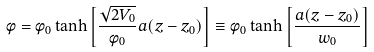<formula> <loc_0><loc_0><loc_500><loc_500>\phi = \phi _ { 0 } \tanh \left [ \frac { \sqrt { 2 V _ { 0 } } } { \phi _ { 0 } } a ( z - z _ { 0 } ) \right ] \equiv \phi _ { 0 } \tanh \left [ \frac { a ( z - z _ { 0 } ) } { w _ { 0 } } \right ]</formula> 